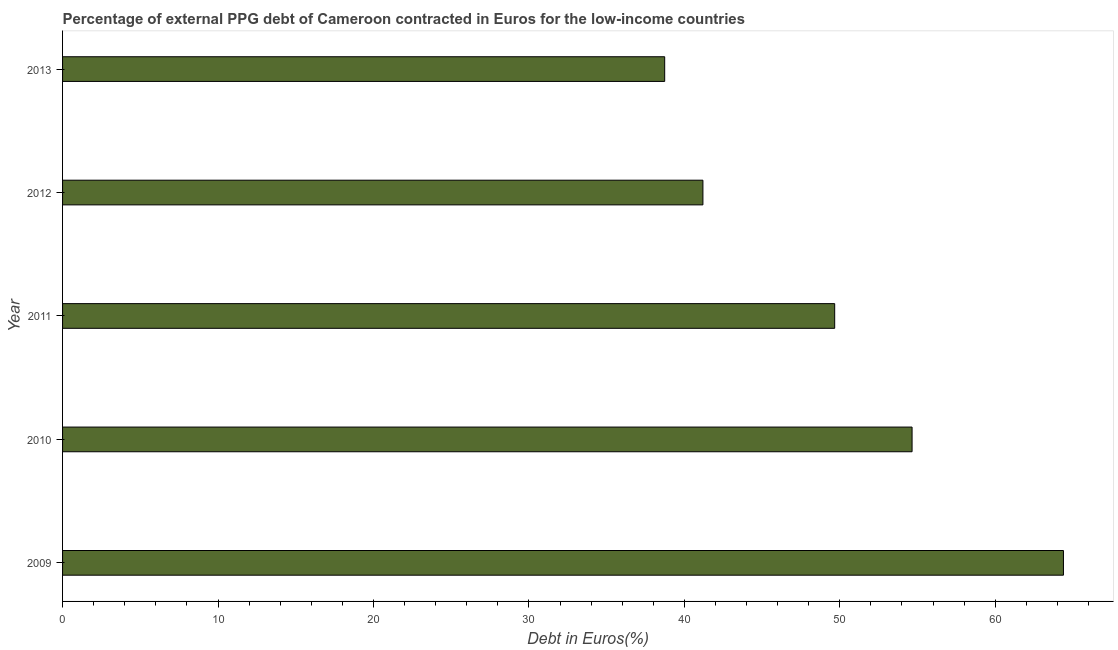Does the graph contain any zero values?
Your response must be concise. No. What is the title of the graph?
Your response must be concise. Percentage of external PPG debt of Cameroon contracted in Euros for the low-income countries. What is the label or title of the X-axis?
Provide a succinct answer. Debt in Euros(%). What is the label or title of the Y-axis?
Offer a terse response. Year. What is the currency composition of ppg debt in 2012?
Offer a very short reply. 41.19. Across all years, what is the maximum currency composition of ppg debt?
Provide a short and direct response. 64.39. Across all years, what is the minimum currency composition of ppg debt?
Make the answer very short. 38.73. In which year was the currency composition of ppg debt minimum?
Your answer should be very brief. 2013. What is the sum of the currency composition of ppg debt?
Provide a succinct answer. 248.63. What is the difference between the currency composition of ppg debt in 2010 and 2011?
Provide a succinct answer. 4.98. What is the average currency composition of ppg debt per year?
Your response must be concise. 49.73. What is the median currency composition of ppg debt?
Give a very brief answer. 49.67. Do a majority of the years between 2010 and 2013 (inclusive) have currency composition of ppg debt greater than 2 %?
Ensure brevity in your answer.  Yes. What is the ratio of the currency composition of ppg debt in 2009 to that in 2011?
Offer a very short reply. 1.3. Is the difference between the currency composition of ppg debt in 2010 and 2013 greater than the difference between any two years?
Your response must be concise. No. What is the difference between the highest and the second highest currency composition of ppg debt?
Offer a terse response. 9.74. Is the sum of the currency composition of ppg debt in 2009 and 2012 greater than the maximum currency composition of ppg debt across all years?
Your answer should be compact. Yes. What is the difference between the highest and the lowest currency composition of ppg debt?
Offer a terse response. 25.65. Are all the bars in the graph horizontal?
Your answer should be compact. Yes. Are the values on the major ticks of X-axis written in scientific E-notation?
Give a very brief answer. No. What is the Debt in Euros(%) in 2009?
Make the answer very short. 64.39. What is the Debt in Euros(%) of 2010?
Offer a very short reply. 54.65. What is the Debt in Euros(%) of 2011?
Provide a succinct answer. 49.67. What is the Debt in Euros(%) in 2012?
Your answer should be compact. 41.19. What is the Debt in Euros(%) in 2013?
Your answer should be compact. 38.73. What is the difference between the Debt in Euros(%) in 2009 and 2010?
Offer a terse response. 9.74. What is the difference between the Debt in Euros(%) in 2009 and 2011?
Your answer should be compact. 14.72. What is the difference between the Debt in Euros(%) in 2009 and 2012?
Your response must be concise. 23.19. What is the difference between the Debt in Euros(%) in 2009 and 2013?
Give a very brief answer. 25.65. What is the difference between the Debt in Euros(%) in 2010 and 2011?
Provide a short and direct response. 4.98. What is the difference between the Debt in Euros(%) in 2010 and 2012?
Your answer should be very brief. 13.46. What is the difference between the Debt in Euros(%) in 2010 and 2013?
Provide a short and direct response. 15.91. What is the difference between the Debt in Euros(%) in 2011 and 2012?
Ensure brevity in your answer.  8.48. What is the difference between the Debt in Euros(%) in 2011 and 2013?
Provide a succinct answer. 10.94. What is the difference between the Debt in Euros(%) in 2012 and 2013?
Your answer should be very brief. 2.46. What is the ratio of the Debt in Euros(%) in 2009 to that in 2010?
Keep it short and to the point. 1.18. What is the ratio of the Debt in Euros(%) in 2009 to that in 2011?
Provide a succinct answer. 1.3. What is the ratio of the Debt in Euros(%) in 2009 to that in 2012?
Offer a terse response. 1.56. What is the ratio of the Debt in Euros(%) in 2009 to that in 2013?
Keep it short and to the point. 1.66. What is the ratio of the Debt in Euros(%) in 2010 to that in 2012?
Make the answer very short. 1.33. What is the ratio of the Debt in Euros(%) in 2010 to that in 2013?
Give a very brief answer. 1.41. What is the ratio of the Debt in Euros(%) in 2011 to that in 2012?
Give a very brief answer. 1.21. What is the ratio of the Debt in Euros(%) in 2011 to that in 2013?
Offer a terse response. 1.28. What is the ratio of the Debt in Euros(%) in 2012 to that in 2013?
Make the answer very short. 1.06. 